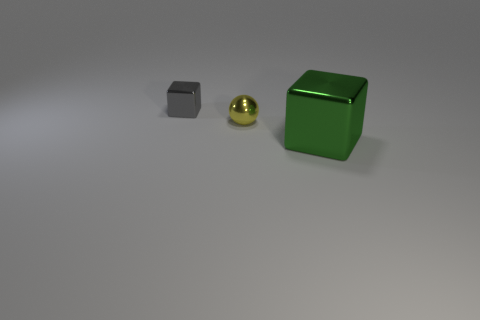What is the shape of the small shiny thing that is in front of the small cube?
Your answer should be very brief. Sphere. Is the number of yellow objects that are to the right of the ball less than the number of objects that are to the right of the tiny cube?
Make the answer very short. Yes. Do the block that is on the left side of the big shiny object and the tiny thing right of the tiny shiny cube have the same material?
Your response must be concise. Yes. What is the shape of the big green thing?
Provide a succinct answer. Cube. Are there more tiny gray cubes that are in front of the ball than big blocks to the left of the gray object?
Your answer should be compact. No. There is a tiny metallic object that is in front of the gray thing; is its shape the same as the green metal thing that is in front of the gray metal object?
Your response must be concise. No. What number of other things are the same size as the gray thing?
Provide a short and direct response. 1. How big is the yellow metallic object?
Offer a very short reply. Small. Is the material of the block that is on the left side of the big green metal object the same as the tiny yellow sphere?
Make the answer very short. Yes. There is another small thing that is the same shape as the green metallic thing; what is its color?
Your answer should be very brief. Gray. 